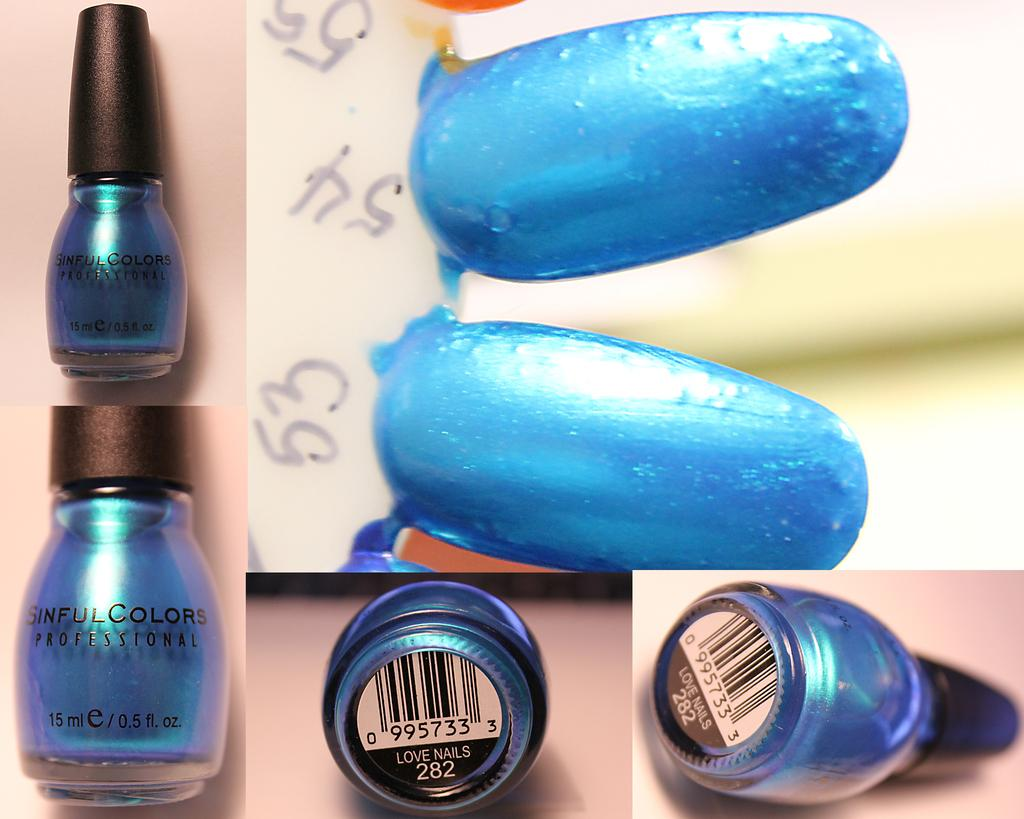Provide a one-sentence caption for the provided image. The blue nail polish is color number 282. 